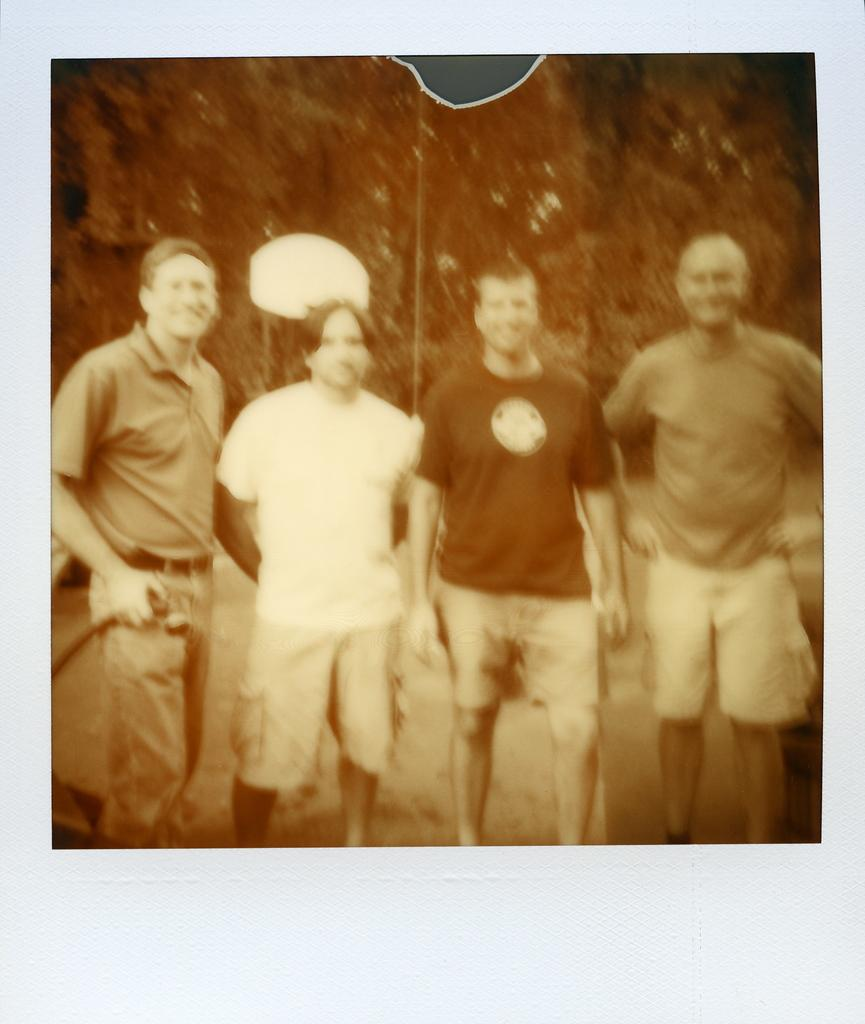How many people are in the image? There are four people in the image. What are the people doing in the image? The people are standing in the image. What expressions do the people have in the image? The people are smiling in the image. Can you describe the background of the image? The background of the image is blurry. Are there any objects visible in the background? Yes, there are a few objects visible in the background. What type of brick is being used to build the pot on the side in the image? There is no brick or pot visible in the image. 